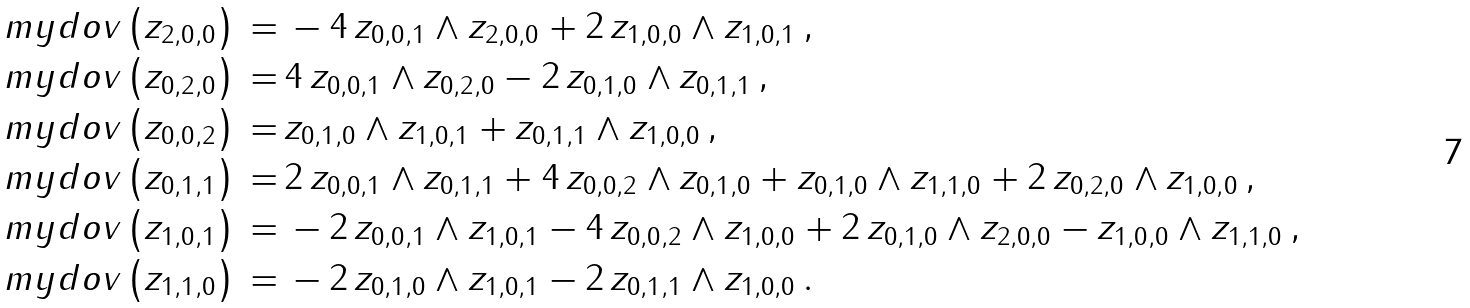Convert formula to latex. <formula><loc_0><loc_0><loc_500><loc_500>\ m y d o v \left ( z _ { 2 , 0 , 0 } \right ) \, = & \, - 4 \, z _ { 0 , 0 , 1 } \wedge z _ { 2 , 0 , 0 } + 2 \, z _ { 1 , 0 , 0 } \wedge z _ { 1 , 0 , 1 } \, , \\ \ m y d o v \left ( z _ { 0 , 2 , 0 } \right ) \, = & \, 4 \, z _ { 0 , 0 , 1 } \wedge z _ { 0 , 2 , 0 } - 2 \, z _ { 0 , 1 , 0 } \wedge z _ { 0 , 1 , 1 } \, , \\ \ m y d o v \left ( z _ { 0 , 0 , 2 } \right ) \, = & \, z _ { 0 , 1 , 0 } \wedge z _ { 1 , 0 , 1 } + z _ { 0 , 1 , 1 } \wedge z _ { 1 , 0 , 0 } \, , \\ \ m y d o v \left ( z _ { 0 , 1 , 1 } \right ) \, = & \, 2 \, z _ { 0 , 0 , 1 } \wedge z _ { 0 , 1 , 1 } + 4 \, z _ { 0 , 0 , 2 } \wedge z _ { 0 , 1 , 0 } + z _ { 0 , 1 , 0 } \wedge z _ { 1 , 1 , 0 } + 2 \, z _ { 0 , 2 , 0 } \wedge z _ { 1 , 0 , 0 } \, , \\ \ m y d o v \left ( z _ { 1 , 0 , 1 } \right ) \, = & \, - 2 \, z _ { 0 , 0 , 1 } \wedge z _ { 1 , 0 , 1 } - 4 \, z _ { 0 , 0 , 2 } \wedge z _ { 1 , 0 , 0 } + 2 \, z _ { 0 , 1 , 0 } \wedge z _ { 2 , 0 , 0 } - z _ { 1 , 0 , 0 } \wedge z _ { 1 , 1 , 0 } \, , \\ \ m y d o v \left ( z _ { 1 , 1 , 0 } \right ) \, = & \, - 2 \, z _ { 0 , 1 , 0 } \wedge z _ { 1 , 0 , 1 } - 2 \, z _ { 0 , 1 , 1 } \wedge z _ { 1 , 0 , 0 } \, .</formula> 